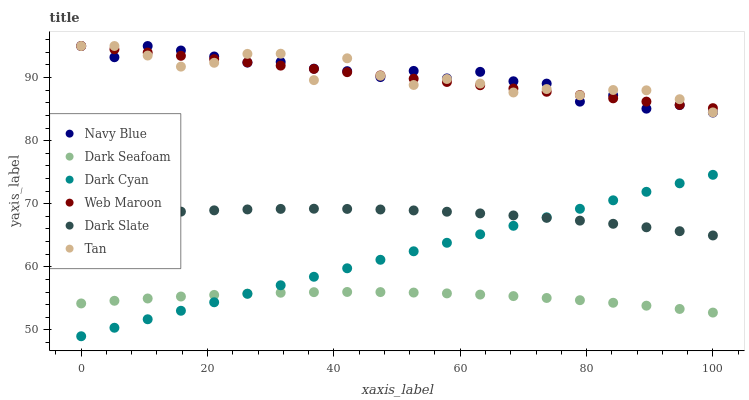Does Dark Seafoam have the minimum area under the curve?
Answer yes or no. Yes. Does Navy Blue have the maximum area under the curve?
Answer yes or no. Yes. Does Web Maroon have the minimum area under the curve?
Answer yes or no. No. Does Web Maroon have the maximum area under the curve?
Answer yes or no. No. Is Dark Cyan the smoothest?
Answer yes or no. Yes. Is Tan the roughest?
Answer yes or no. Yes. Is Web Maroon the smoothest?
Answer yes or no. No. Is Web Maroon the roughest?
Answer yes or no. No. Does Dark Cyan have the lowest value?
Answer yes or no. Yes. Does Dark Slate have the lowest value?
Answer yes or no. No. Does Tan have the highest value?
Answer yes or no. Yes. Does Dark Slate have the highest value?
Answer yes or no. No. Is Dark Slate less than Tan?
Answer yes or no. Yes. Is Tan greater than Dark Slate?
Answer yes or no. Yes. Does Dark Seafoam intersect Dark Cyan?
Answer yes or no. Yes. Is Dark Seafoam less than Dark Cyan?
Answer yes or no. No. Is Dark Seafoam greater than Dark Cyan?
Answer yes or no. No. Does Dark Slate intersect Tan?
Answer yes or no. No. 